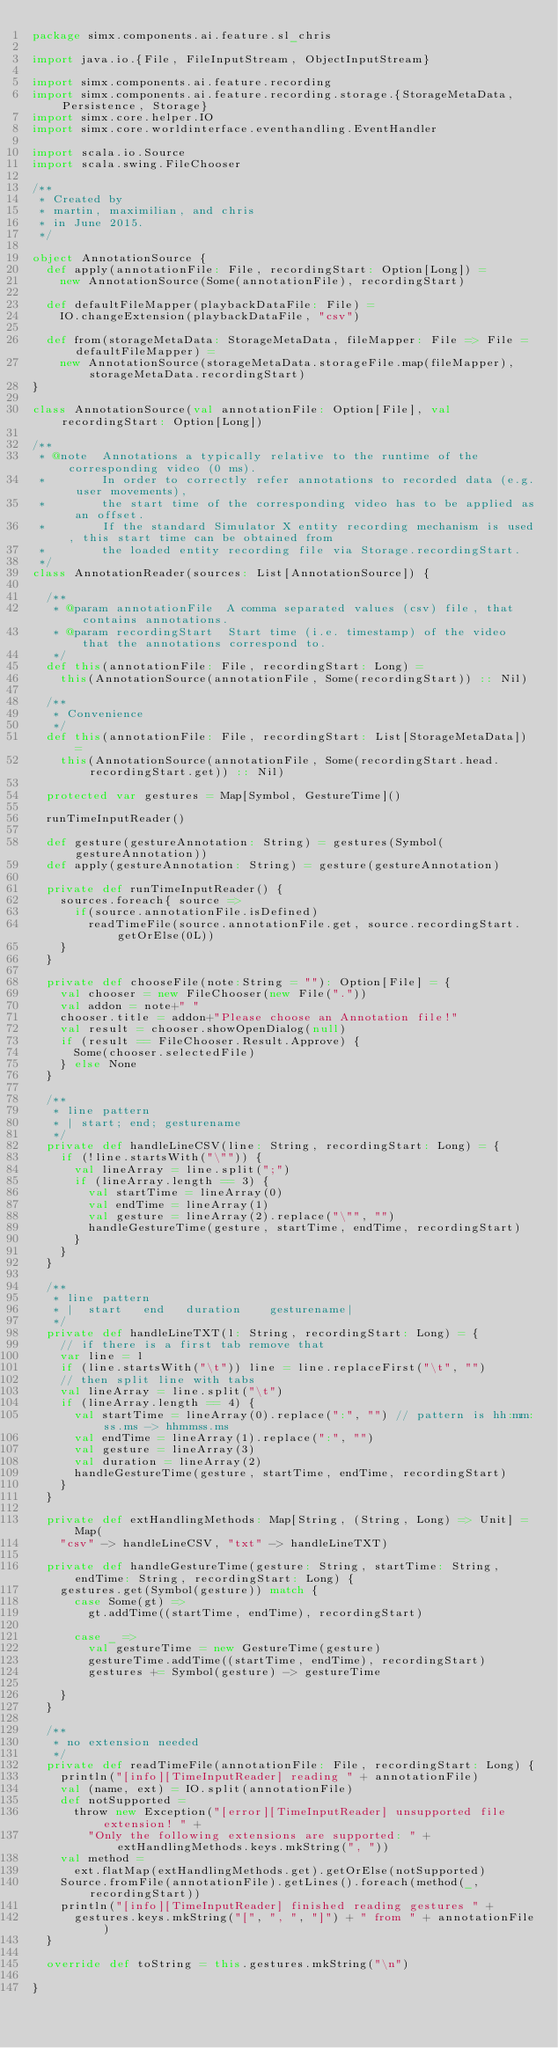<code> <loc_0><loc_0><loc_500><loc_500><_Scala_>package simx.components.ai.feature.sl_chris

import java.io.{File, FileInputStream, ObjectInputStream}

import simx.components.ai.feature.recording
import simx.components.ai.feature.recording.storage.{StorageMetaData, Persistence, Storage}
import simx.core.helper.IO
import simx.core.worldinterface.eventhandling.EventHandler

import scala.io.Source
import scala.swing.FileChooser

/**
 * Created by
 * martin, maximilian, and chris
 * in June 2015.
 */

object AnnotationSource {
  def apply(annotationFile: File, recordingStart: Option[Long]) =
    new AnnotationSource(Some(annotationFile), recordingStart)

  def defaultFileMapper(playbackDataFile: File) =
    IO.changeExtension(playbackDataFile, "csv")

  def from(storageMetaData: StorageMetaData, fileMapper: File => File = defaultFileMapper) =
    new AnnotationSource(storageMetaData.storageFile.map(fileMapper), storageMetaData.recordingStart)
}

class AnnotationSource(val annotationFile: Option[File], val recordingStart: Option[Long])

/**
 * @note  Annotations a typically relative to the runtime of the corresponding video (0 ms).
 *        In order to correctly refer annotations to recorded data (e.g. user movements),
 *        the start time of the corresponding video has to be applied as an offset.
 *        If the standard Simulator X entity recording mechanism is used, this start time can be obtained from
 *        the loaded entity recording file via Storage.recordingStart.
 */
class AnnotationReader(sources: List[AnnotationSource]) {

  /**
   * @param annotationFile  A comma separated values (csv) file, that contains annotations.
   * @param recordingStart  Start time (i.e. timestamp) of the video that the annotations correspond to.
   */
  def this(annotationFile: File, recordingStart: Long) =
    this(AnnotationSource(annotationFile, Some(recordingStart)) :: Nil)

  /**
   * Convenience
   */
  def this(annotationFile: File, recordingStart: List[StorageMetaData]) =
    this(AnnotationSource(annotationFile, Some(recordingStart.head.recordingStart.get)) :: Nil)

  protected var gestures = Map[Symbol, GestureTime]()

  runTimeInputReader()

  def gesture(gestureAnnotation: String) = gestures(Symbol(gestureAnnotation))
  def apply(gestureAnnotation: String) = gesture(gestureAnnotation)

  private def runTimeInputReader() {
    sources.foreach{ source =>
      if(source.annotationFile.isDefined)
        readTimeFile(source.annotationFile.get, source.recordingStart.getOrElse(0L))
    }
  }

  private def chooseFile(note:String = ""): Option[File] = {
    val chooser = new FileChooser(new File("."))
    val addon = note+" "
    chooser.title = addon+"Please choose an Annotation file!"
    val result = chooser.showOpenDialog(null)
    if (result == FileChooser.Result.Approve) {
      Some(chooser.selectedFile)
    } else None
  }

  /**
   * line pattern
   * | start; end; gesturename
   */
  private def handleLineCSV(line: String, recordingStart: Long) = {
    if (!line.startsWith("\"")) {
      val lineArray = line.split(";")
      if (lineArray.length == 3) {
        val startTime = lineArray(0)
        val endTime = lineArray(1)
        val gesture = lineArray(2).replace("\"", "")
        handleGestureTime(gesture, startTime, endTime, recordingStart)
      }
    }
  }

  /**
   * line pattern
   * |  start   end   duration    gesturename|
   */
  private def handleLineTXT(l: String, recordingStart: Long) = {
    // if there is a first tab remove that
    var line = l
    if (line.startsWith("\t")) line = line.replaceFirst("\t", "")
    // then split line with tabs
    val lineArray = line.split("\t")
    if (lineArray.length == 4) {
      val startTime = lineArray(0).replace(":", "") // pattern is hh:mm:ss.ms -> hhmmss.ms
      val endTime = lineArray(1).replace(":", "")
      val gesture = lineArray(3)
      val duration = lineArray(2)
      handleGestureTime(gesture, startTime, endTime, recordingStart)
    }
  }

  private def extHandlingMethods: Map[String, (String, Long) => Unit] = Map(
    "csv" -> handleLineCSV, "txt" -> handleLineTXT)

  private def handleGestureTime(gesture: String, startTime: String, endTime: String, recordingStart: Long) {
    gestures.get(Symbol(gesture)) match {
      case Some(gt) =>
        gt.addTime((startTime, endTime), recordingStart)

      case _ =>
        val gestureTime = new GestureTime(gesture)
        gestureTime.addTime((startTime, endTime), recordingStart)
        gestures += Symbol(gesture) -> gestureTime

    }
  }

  /**
   * no extension needed
   */
  private def readTimeFile(annotationFile: File, recordingStart: Long) {
    println("[info][TimeInputReader] reading " + annotationFile)
    val (name, ext) = IO.split(annotationFile)
    def notSupported =
      throw new Exception("[error][TimeInputReader] unsupported file extension! " +
        "Only the following extensions are supported: " + extHandlingMethods.keys.mkString(", "))
    val method =
      ext.flatMap(extHandlingMethods.get).getOrElse(notSupported)
    Source.fromFile(annotationFile).getLines().foreach(method(_, recordingStart))
    println("[info][TimeInputReader] finished reading gestures " +
      gestures.keys.mkString("[", ", ", "]") + " from " + annotationFile)
  }

  override def toString = this.gestures.mkString("\n")

}</code> 